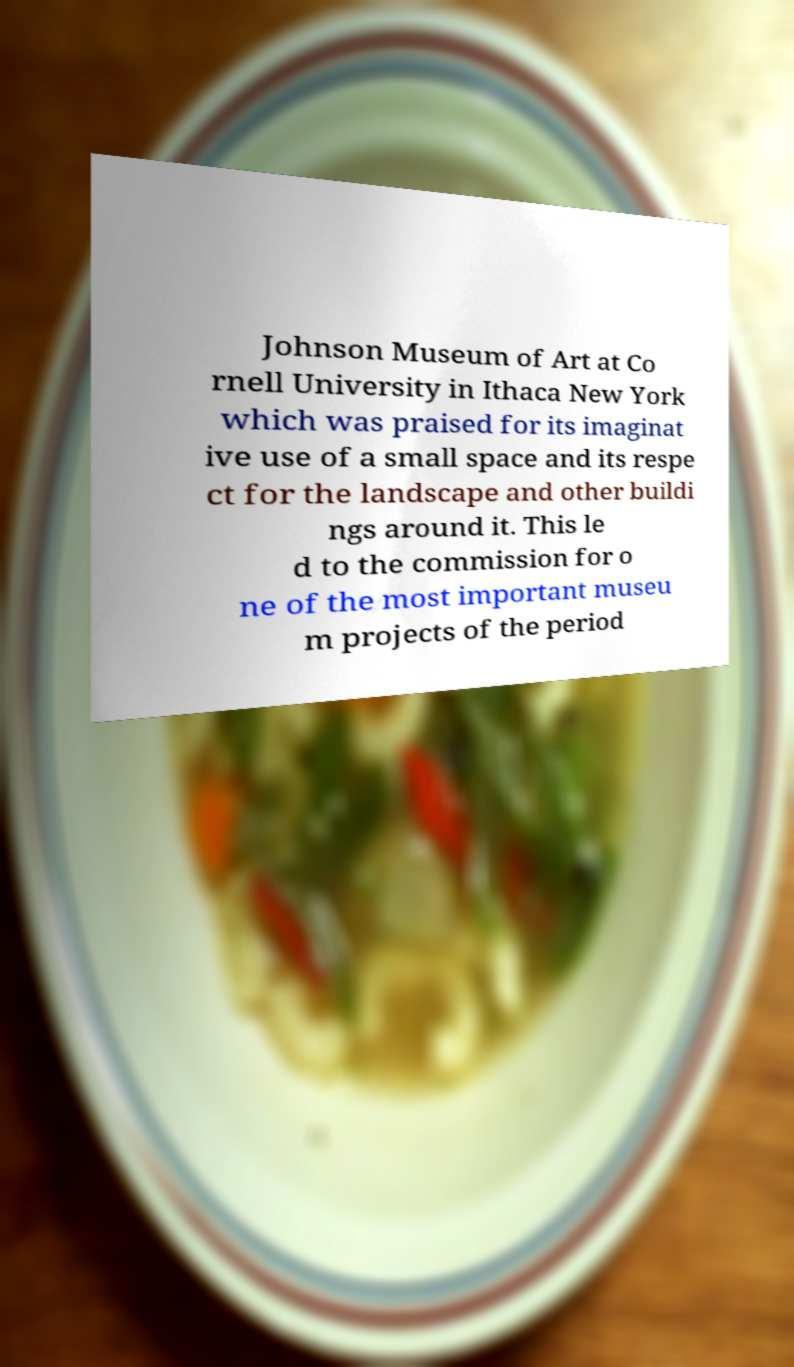Please read and relay the text visible in this image. What does it say? Johnson Museum of Art at Co rnell University in Ithaca New York which was praised for its imaginat ive use of a small space and its respe ct for the landscape and other buildi ngs around it. This le d to the commission for o ne of the most important museu m projects of the period 